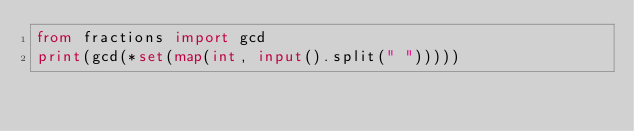Convert code to text. <code><loc_0><loc_0><loc_500><loc_500><_Python_>from fractions import gcd
print(gcd(*set(map(int, input().split(" ")))))</code> 